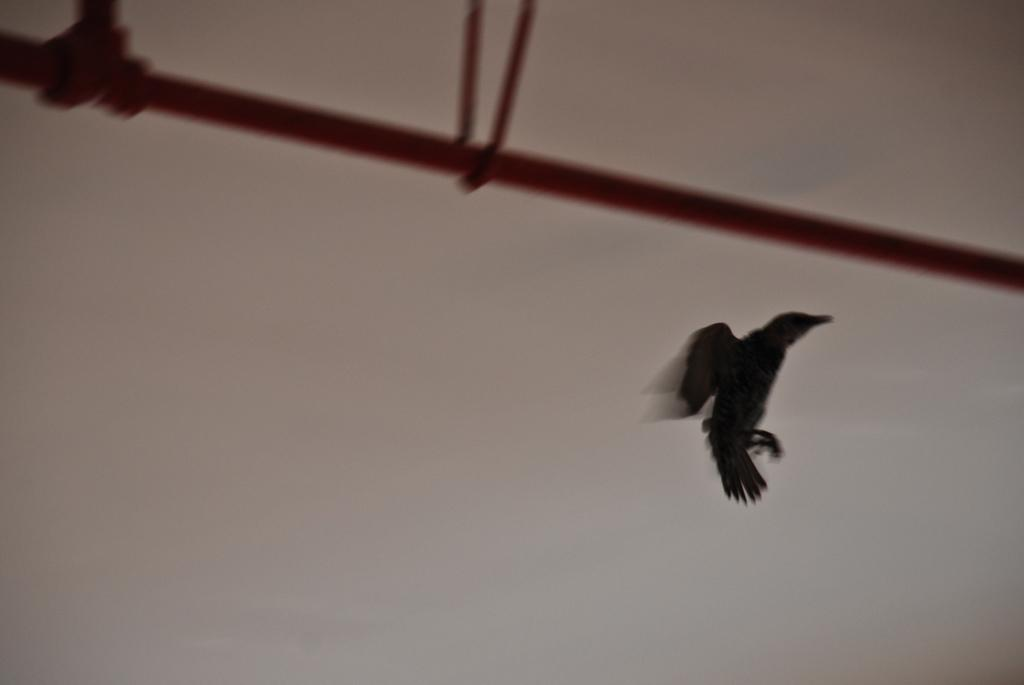What is the main subject of the image? There is a bird flying in the air in the image. What else can be seen in the image besides the bird? There is a rod and other objects in the image. What is visible in the background of the image? The sky is visible in the background of the image. What type of crime is being committed by the goat in the image? There is no goat present in the image, and therefore no crime can be observed. What color is the silver object in the image? There is no silver object present in the image. 